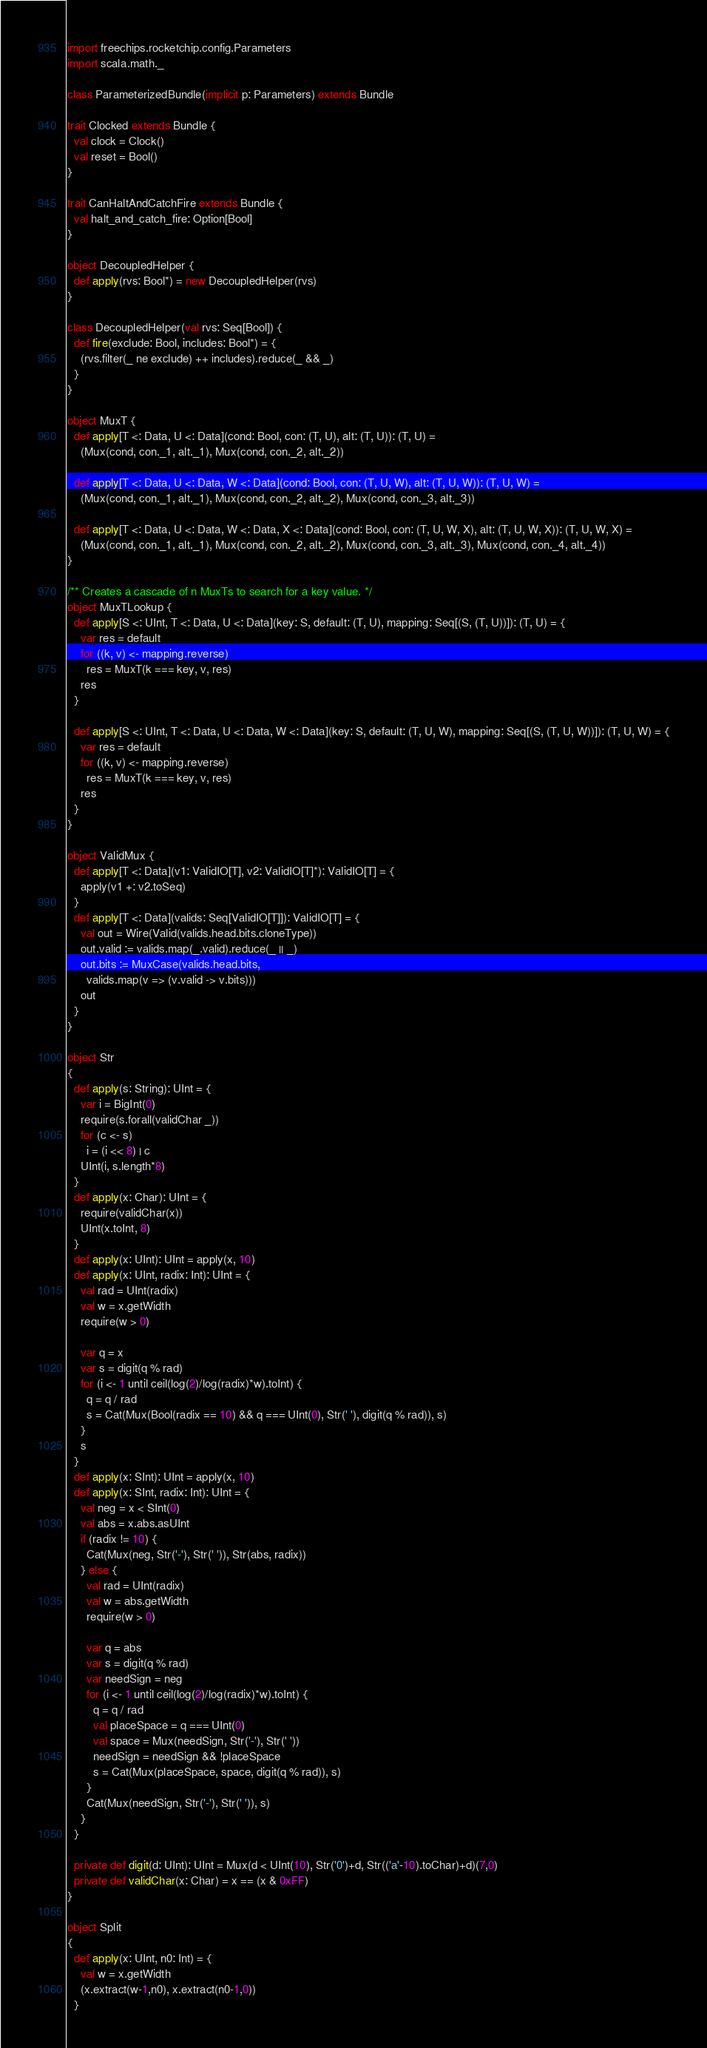<code> <loc_0><loc_0><loc_500><loc_500><_Scala_>import freechips.rocketchip.config.Parameters
import scala.math._

class ParameterizedBundle(implicit p: Parameters) extends Bundle

trait Clocked extends Bundle {
  val clock = Clock()
  val reset = Bool()  
}

trait CanHaltAndCatchFire extends Bundle {
  val halt_and_catch_fire: Option[Bool]
}

object DecoupledHelper {
  def apply(rvs: Bool*) = new DecoupledHelper(rvs)
}

class DecoupledHelper(val rvs: Seq[Bool]) {
  def fire(exclude: Bool, includes: Bool*) = {
    (rvs.filter(_ ne exclude) ++ includes).reduce(_ && _)
  }
}

object MuxT {
  def apply[T <: Data, U <: Data](cond: Bool, con: (T, U), alt: (T, U)): (T, U) =
    (Mux(cond, con._1, alt._1), Mux(cond, con._2, alt._2))

  def apply[T <: Data, U <: Data, W <: Data](cond: Bool, con: (T, U, W), alt: (T, U, W)): (T, U, W) =
    (Mux(cond, con._1, alt._1), Mux(cond, con._2, alt._2), Mux(cond, con._3, alt._3))

  def apply[T <: Data, U <: Data, W <: Data, X <: Data](cond: Bool, con: (T, U, W, X), alt: (T, U, W, X)): (T, U, W, X) =
    (Mux(cond, con._1, alt._1), Mux(cond, con._2, alt._2), Mux(cond, con._3, alt._3), Mux(cond, con._4, alt._4))
}

/** Creates a cascade of n MuxTs to search for a key value. */
object MuxTLookup {
  def apply[S <: UInt, T <: Data, U <: Data](key: S, default: (T, U), mapping: Seq[(S, (T, U))]): (T, U) = {
    var res = default
    for ((k, v) <- mapping.reverse)
      res = MuxT(k === key, v, res)
    res
  }

  def apply[S <: UInt, T <: Data, U <: Data, W <: Data](key: S, default: (T, U, W), mapping: Seq[(S, (T, U, W))]): (T, U, W) = {
    var res = default
    for ((k, v) <- mapping.reverse)
      res = MuxT(k === key, v, res)
    res
  }
}

object ValidMux {
  def apply[T <: Data](v1: ValidIO[T], v2: ValidIO[T]*): ValidIO[T] = {
    apply(v1 +: v2.toSeq)
  }
  def apply[T <: Data](valids: Seq[ValidIO[T]]): ValidIO[T] = {
    val out = Wire(Valid(valids.head.bits.cloneType))
    out.valid := valids.map(_.valid).reduce(_ || _)
    out.bits := MuxCase(valids.head.bits,
      valids.map(v => (v.valid -> v.bits)))
    out
  }
}

object Str
{
  def apply(s: String): UInt = {
    var i = BigInt(0)
    require(s.forall(validChar _))
    for (c <- s)
      i = (i << 8) | c
    UInt(i, s.length*8)
  }
  def apply(x: Char): UInt = {
    require(validChar(x))
    UInt(x.toInt, 8)
  }
  def apply(x: UInt): UInt = apply(x, 10)
  def apply(x: UInt, radix: Int): UInt = {
    val rad = UInt(radix)
    val w = x.getWidth
    require(w > 0)

    var q = x
    var s = digit(q % rad)
    for (i <- 1 until ceil(log(2)/log(radix)*w).toInt) {
      q = q / rad
      s = Cat(Mux(Bool(radix == 10) && q === UInt(0), Str(' '), digit(q % rad)), s)
    }
    s
  }
  def apply(x: SInt): UInt = apply(x, 10)
  def apply(x: SInt, radix: Int): UInt = {
    val neg = x < SInt(0)
    val abs = x.abs.asUInt
    if (radix != 10) {
      Cat(Mux(neg, Str('-'), Str(' ')), Str(abs, radix))
    } else {
      val rad = UInt(radix)
      val w = abs.getWidth
      require(w > 0)

      var q = abs
      var s = digit(q % rad)
      var needSign = neg
      for (i <- 1 until ceil(log(2)/log(radix)*w).toInt) {
        q = q / rad
        val placeSpace = q === UInt(0)
        val space = Mux(needSign, Str('-'), Str(' '))
        needSign = needSign && !placeSpace
        s = Cat(Mux(placeSpace, space, digit(q % rad)), s)
      }
      Cat(Mux(needSign, Str('-'), Str(' ')), s)
    }
  }

  private def digit(d: UInt): UInt = Mux(d < UInt(10), Str('0')+d, Str(('a'-10).toChar)+d)(7,0)
  private def validChar(x: Char) = x == (x & 0xFF)
}

object Split
{
  def apply(x: UInt, n0: Int) = {
    val w = x.getWidth
    (x.extract(w-1,n0), x.extract(n0-1,0))
  }</code> 